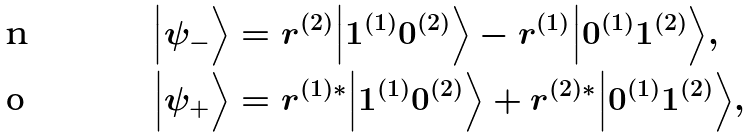Convert formula to latex. <formula><loc_0><loc_0><loc_500><loc_500>\Big | \psi _ { - } \Big \rangle & = r ^ { ( 2 ) } \Big | 1 ^ { ( 1 ) } 0 ^ { ( 2 ) } \Big \rangle - r ^ { ( 1 ) } \Big | 0 ^ { ( 1 ) } 1 ^ { ( 2 ) } \Big \rangle , \\ \Big | \psi _ { + } \Big \rangle & = r ^ { ( 1 ) * } \Big | 1 ^ { ( 1 ) } 0 ^ { ( 2 ) } \Big \rangle + r ^ { ( 2 ) * } \Big | 0 ^ { ( 1 ) } 1 ^ { ( 2 ) } \Big \rangle ,</formula> 